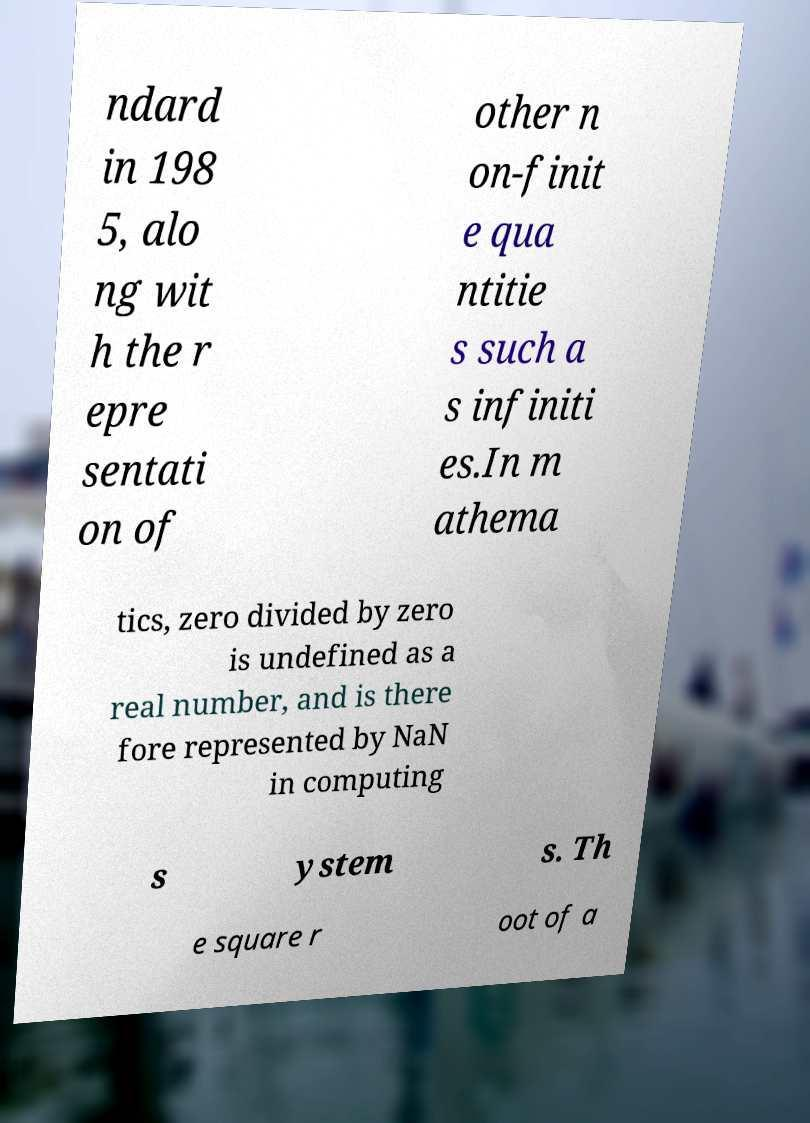What messages or text are displayed in this image? I need them in a readable, typed format. ndard in 198 5, alo ng wit h the r epre sentati on of other n on-finit e qua ntitie s such a s infiniti es.In m athema tics, zero divided by zero is undefined as a real number, and is there fore represented by NaN in computing s ystem s. Th e square r oot of a 